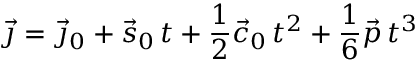Convert formula to latex. <formula><loc_0><loc_0><loc_500><loc_500>{ \vec { \jmath } } = { \vec { \jmath } } _ { 0 } + { \vec { s } } _ { 0 } \, t + { \frac { 1 } { 2 } } { \vec { c } } _ { 0 } \, t ^ { 2 } + { \frac { 1 } { 6 } } { \vec { p } } \, t ^ { 3 }</formula> 